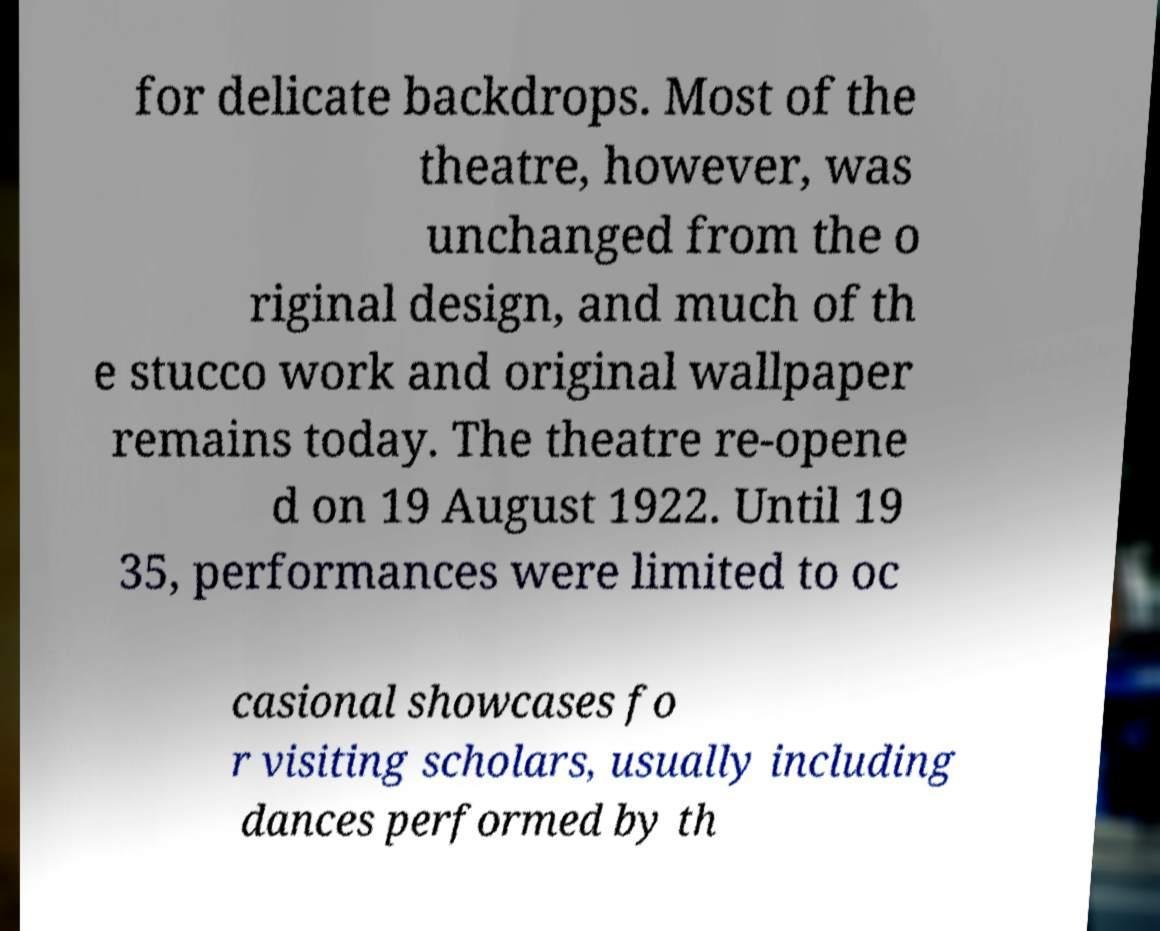Please identify and transcribe the text found in this image. for delicate backdrops. Most of the theatre, however, was unchanged from the o riginal design, and much of th e stucco work and original wallpaper remains today. The theatre re-opene d on 19 August 1922. Until 19 35, performances were limited to oc casional showcases fo r visiting scholars, usually including dances performed by th 